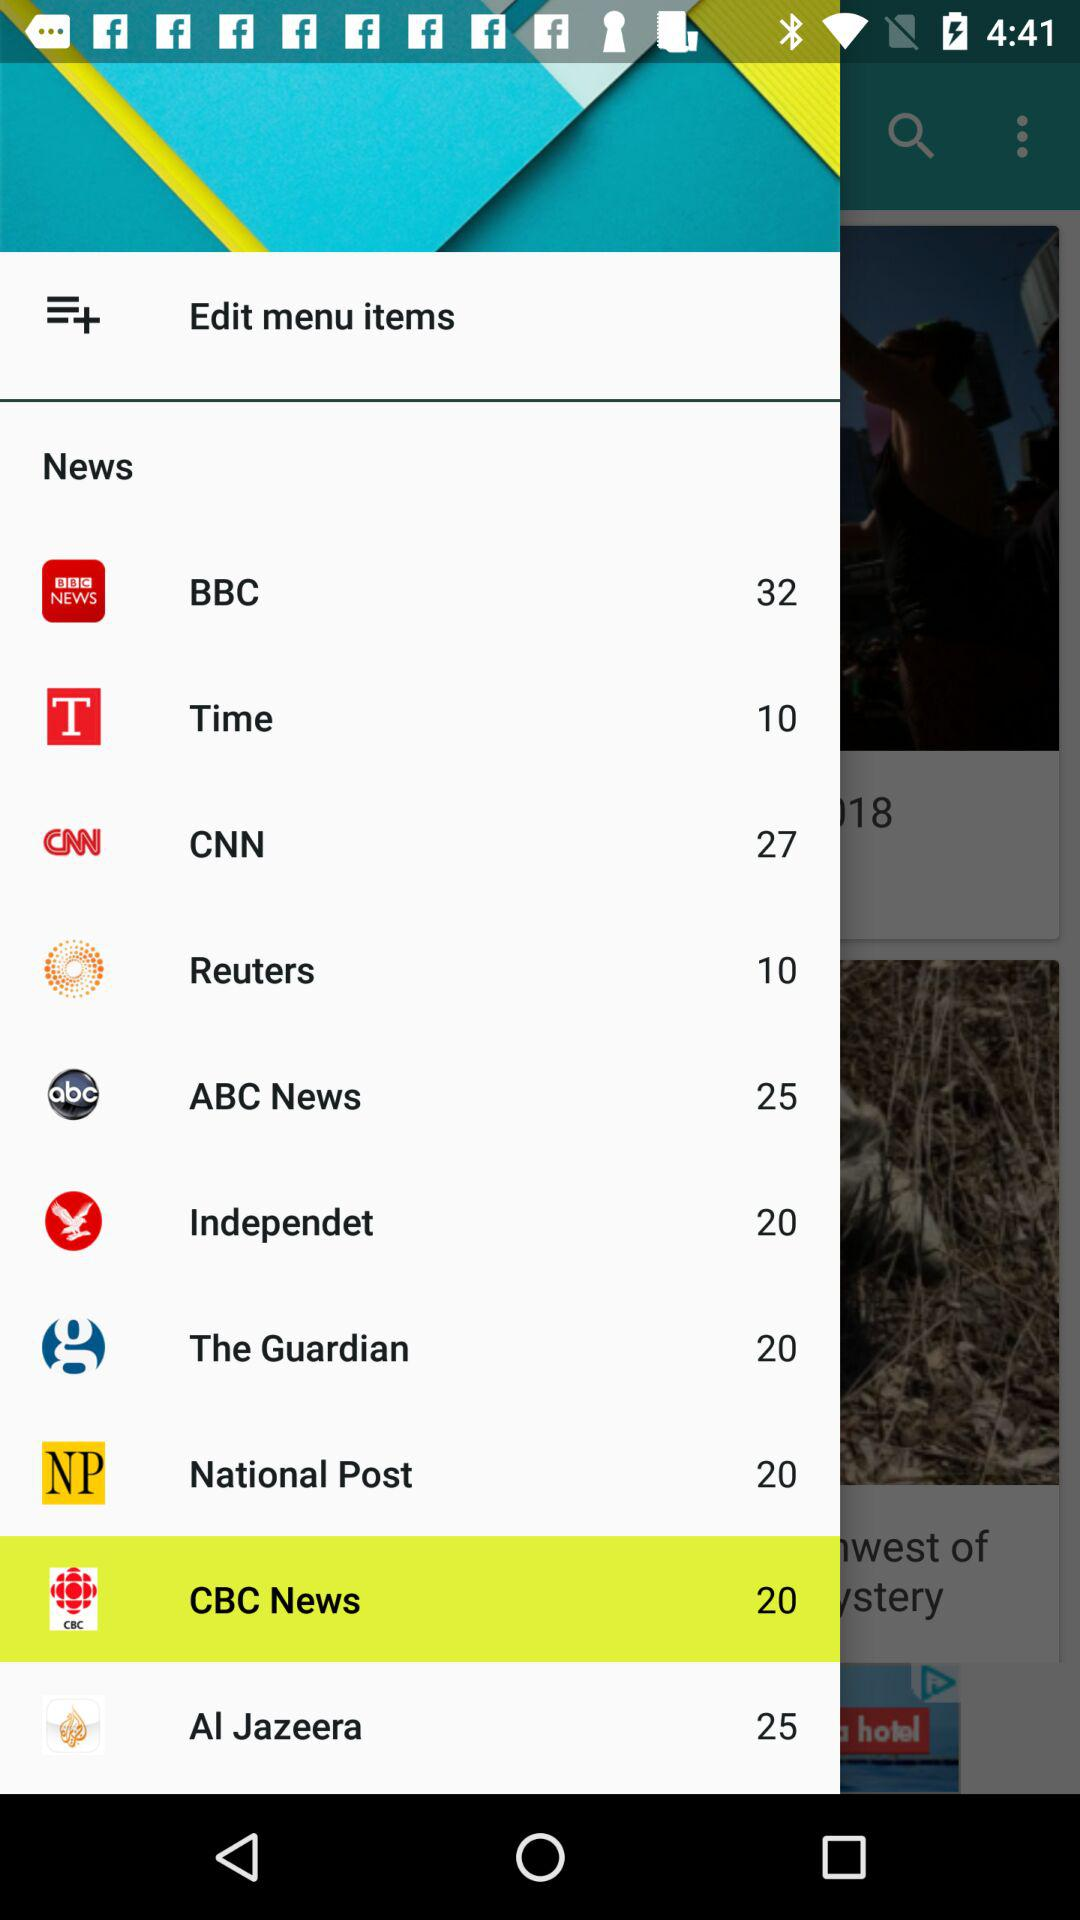What news channel has 27 news? The channel that has 27 news is CNN. 